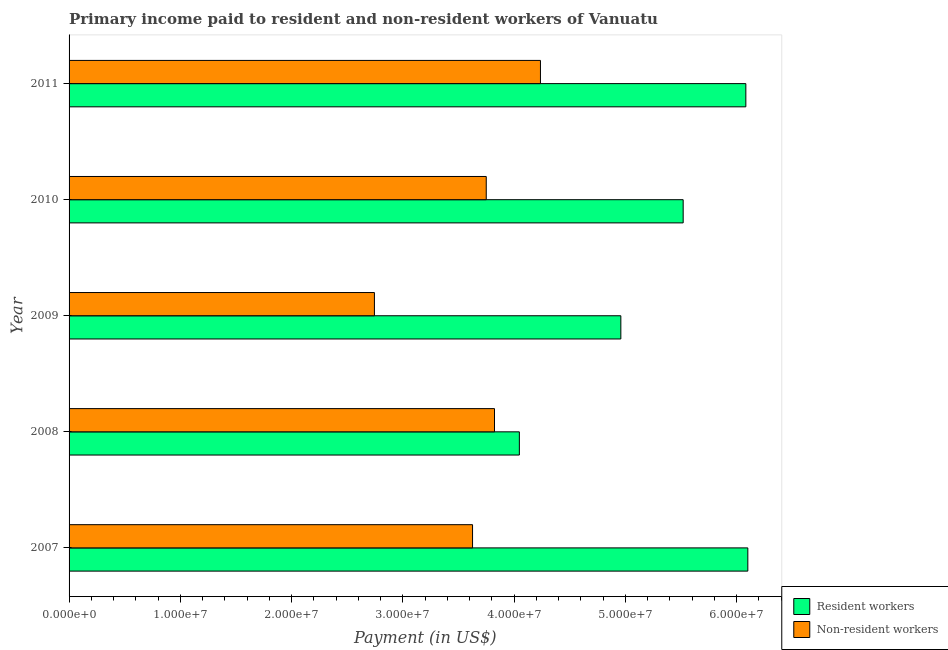How many groups of bars are there?
Your response must be concise. 5. Are the number of bars per tick equal to the number of legend labels?
Your response must be concise. Yes. How many bars are there on the 3rd tick from the top?
Your answer should be compact. 2. What is the payment made to resident workers in 2008?
Your response must be concise. 4.05e+07. Across all years, what is the maximum payment made to resident workers?
Give a very brief answer. 6.10e+07. Across all years, what is the minimum payment made to non-resident workers?
Offer a terse response. 2.74e+07. What is the total payment made to resident workers in the graph?
Keep it short and to the point. 2.67e+08. What is the difference between the payment made to non-resident workers in 2009 and that in 2011?
Give a very brief answer. -1.49e+07. What is the difference between the payment made to non-resident workers in 2008 and the payment made to resident workers in 2011?
Your answer should be very brief. -2.26e+07. What is the average payment made to resident workers per year?
Provide a short and direct response. 5.34e+07. In the year 2008, what is the difference between the payment made to resident workers and payment made to non-resident workers?
Your response must be concise. 2.23e+06. In how many years, is the payment made to resident workers greater than 26000000 US$?
Your answer should be very brief. 5. What is the ratio of the payment made to resident workers in 2007 to that in 2008?
Make the answer very short. 1.51. Is the payment made to resident workers in 2007 less than that in 2010?
Your answer should be very brief. No. Is the difference between the payment made to resident workers in 2008 and 2011 greater than the difference between the payment made to non-resident workers in 2008 and 2011?
Keep it short and to the point. No. What is the difference between the highest and the second highest payment made to non-resident workers?
Give a very brief answer. 4.13e+06. What is the difference between the highest and the lowest payment made to resident workers?
Keep it short and to the point. 2.05e+07. What does the 2nd bar from the top in 2010 represents?
Keep it short and to the point. Resident workers. What does the 2nd bar from the bottom in 2009 represents?
Keep it short and to the point. Non-resident workers. How many bars are there?
Provide a succinct answer. 10. Are all the bars in the graph horizontal?
Your answer should be compact. Yes. What is the difference between two consecutive major ticks on the X-axis?
Provide a short and direct response. 1.00e+07. Does the graph contain any zero values?
Make the answer very short. No. Does the graph contain grids?
Your answer should be very brief. No. How many legend labels are there?
Give a very brief answer. 2. What is the title of the graph?
Your answer should be compact. Primary income paid to resident and non-resident workers of Vanuatu. Does "Domestic liabilities" appear as one of the legend labels in the graph?
Your response must be concise. No. What is the label or title of the X-axis?
Provide a succinct answer. Payment (in US$). What is the label or title of the Y-axis?
Offer a terse response. Year. What is the Payment (in US$) in Resident workers in 2007?
Keep it short and to the point. 6.10e+07. What is the Payment (in US$) of Non-resident workers in 2007?
Make the answer very short. 3.63e+07. What is the Payment (in US$) of Resident workers in 2008?
Keep it short and to the point. 4.05e+07. What is the Payment (in US$) in Non-resident workers in 2008?
Keep it short and to the point. 3.82e+07. What is the Payment (in US$) in Resident workers in 2009?
Provide a succinct answer. 4.96e+07. What is the Payment (in US$) in Non-resident workers in 2009?
Ensure brevity in your answer.  2.74e+07. What is the Payment (in US$) of Resident workers in 2010?
Give a very brief answer. 5.52e+07. What is the Payment (in US$) in Non-resident workers in 2010?
Give a very brief answer. 3.75e+07. What is the Payment (in US$) in Resident workers in 2011?
Provide a short and direct response. 6.08e+07. What is the Payment (in US$) of Non-resident workers in 2011?
Give a very brief answer. 4.24e+07. Across all years, what is the maximum Payment (in US$) of Resident workers?
Your answer should be very brief. 6.10e+07. Across all years, what is the maximum Payment (in US$) of Non-resident workers?
Ensure brevity in your answer.  4.24e+07. Across all years, what is the minimum Payment (in US$) of Resident workers?
Make the answer very short. 4.05e+07. Across all years, what is the minimum Payment (in US$) of Non-resident workers?
Make the answer very short. 2.74e+07. What is the total Payment (in US$) in Resident workers in the graph?
Offer a terse response. 2.67e+08. What is the total Payment (in US$) in Non-resident workers in the graph?
Give a very brief answer. 1.82e+08. What is the difference between the Payment (in US$) in Resident workers in 2007 and that in 2008?
Ensure brevity in your answer.  2.05e+07. What is the difference between the Payment (in US$) of Non-resident workers in 2007 and that in 2008?
Your response must be concise. -1.97e+06. What is the difference between the Payment (in US$) in Resident workers in 2007 and that in 2009?
Offer a terse response. 1.14e+07. What is the difference between the Payment (in US$) of Non-resident workers in 2007 and that in 2009?
Provide a succinct answer. 8.82e+06. What is the difference between the Payment (in US$) of Resident workers in 2007 and that in 2010?
Make the answer very short. 5.81e+06. What is the difference between the Payment (in US$) in Non-resident workers in 2007 and that in 2010?
Keep it short and to the point. -1.23e+06. What is the difference between the Payment (in US$) of Resident workers in 2007 and that in 2011?
Give a very brief answer. 1.78e+05. What is the difference between the Payment (in US$) in Non-resident workers in 2007 and that in 2011?
Your answer should be compact. -6.10e+06. What is the difference between the Payment (in US$) in Resident workers in 2008 and that in 2009?
Provide a succinct answer. -9.12e+06. What is the difference between the Payment (in US$) in Non-resident workers in 2008 and that in 2009?
Your response must be concise. 1.08e+07. What is the difference between the Payment (in US$) of Resident workers in 2008 and that in 2010?
Offer a very short reply. -1.47e+07. What is the difference between the Payment (in US$) of Non-resident workers in 2008 and that in 2010?
Ensure brevity in your answer.  7.41e+05. What is the difference between the Payment (in US$) in Resident workers in 2008 and that in 2011?
Your answer should be compact. -2.04e+07. What is the difference between the Payment (in US$) in Non-resident workers in 2008 and that in 2011?
Your answer should be very brief. -4.13e+06. What is the difference between the Payment (in US$) in Resident workers in 2009 and that in 2010?
Give a very brief answer. -5.60e+06. What is the difference between the Payment (in US$) of Non-resident workers in 2009 and that in 2010?
Your answer should be very brief. -1.01e+07. What is the difference between the Payment (in US$) of Resident workers in 2009 and that in 2011?
Ensure brevity in your answer.  -1.12e+07. What is the difference between the Payment (in US$) in Non-resident workers in 2009 and that in 2011?
Offer a very short reply. -1.49e+07. What is the difference between the Payment (in US$) of Resident workers in 2010 and that in 2011?
Your response must be concise. -5.63e+06. What is the difference between the Payment (in US$) in Non-resident workers in 2010 and that in 2011?
Provide a succinct answer. -4.87e+06. What is the difference between the Payment (in US$) of Resident workers in 2007 and the Payment (in US$) of Non-resident workers in 2008?
Your answer should be compact. 2.28e+07. What is the difference between the Payment (in US$) in Resident workers in 2007 and the Payment (in US$) in Non-resident workers in 2009?
Provide a short and direct response. 3.36e+07. What is the difference between the Payment (in US$) in Resident workers in 2007 and the Payment (in US$) in Non-resident workers in 2010?
Give a very brief answer. 2.35e+07. What is the difference between the Payment (in US$) of Resident workers in 2007 and the Payment (in US$) of Non-resident workers in 2011?
Your answer should be compact. 1.86e+07. What is the difference between the Payment (in US$) of Resident workers in 2008 and the Payment (in US$) of Non-resident workers in 2009?
Your response must be concise. 1.30e+07. What is the difference between the Payment (in US$) in Resident workers in 2008 and the Payment (in US$) in Non-resident workers in 2010?
Your response must be concise. 2.98e+06. What is the difference between the Payment (in US$) of Resident workers in 2008 and the Payment (in US$) of Non-resident workers in 2011?
Your answer should be compact. -1.90e+06. What is the difference between the Payment (in US$) in Resident workers in 2009 and the Payment (in US$) in Non-resident workers in 2010?
Your response must be concise. 1.21e+07. What is the difference between the Payment (in US$) in Resident workers in 2009 and the Payment (in US$) in Non-resident workers in 2011?
Provide a succinct answer. 7.23e+06. What is the difference between the Payment (in US$) of Resident workers in 2010 and the Payment (in US$) of Non-resident workers in 2011?
Provide a short and direct response. 1.28e+07. What is the average Payment (in US$) of Resident workers per year?
Offer a terse response. 5.34e+07. What is the average Payment (in US$) of Non-resident workers per year?
Give a very brief answer. 3.64e+07. In the year 2007, what is the difference between the Payment (in US$) in Resident workers and Payment (in US$) in Non-resident workers?
Provide a succinct answer. 2.47e+07. In the year 2008, what is the difference between the Payment (in US$) of Resident workers and Payment (in US$) of Non-resident workers?
Keep it short and to the point. 2.23e+06. In the year 2009, what is the difference between the Payment (in US$) in Resident workers and Payment (in US$) in Non-resident workers?
Provide a short and direct response. 2.21e+07. In the year 2010, what is the difference between the Payment (in US$) in Resident workers and Payment (in US$) in Non-resident workers?
Ensure brevity in your answer.  1.77e+07. In the year 2011, what is the difference between the Payment (in US$) of Resident workers and Payment (in US$) of Non-resident workers?
Your response must be concise. 1.85e+07. What is the ratio of the Payment (in US$) of Resident workers in 2007 to that in 2008?
Offer a very short reply. 1.51. What is the ratio of the Payment (in US$) of Non-resident workers in 2007 to that in 2008?
Your answer should be compact. 0.95. What is the ratio of the Payment (in US$) of Resident workers in 2007 to that in 2009?
Your answer should be compact. 1.23. What is the ratio of the Payment (in US$) of Non-resident workers in 2007 to that in 2009?
Your response must be concise. 1.32. What is the ratio of the Payment (in US$) in Resident workers in 2007 to that in 2010?
Ensure brevity in your answer.  1.11. What is the ratio of the Payment (in US$) in Non-resident workers in 2007 to that in 2010?
Offer a very short reply. 0.97. What is the ratio of the Payment (in US$) of Non-resident workers in 2007 to that in 2011?
Give a very brief answer. 0.86. What is the ratio of the Payment (in US$) of Resident workers in 2008 to that in 2009?
Your response must be concise. 0.82. What is the ratio of the Payment (in US$) of Non-resident workers in 2008 to that in 2009?
Make the answer very short. 1.39. What is the ratio of the Payment (in US$) in Resident workers in 2008 to that in 2010?
Your response must be concise. 0.73. What is the ratio of the Payment (in US$) of Non-resident workers in 2008 to that in 2010?
Offer a very short reply. 1.02. What is the ratio of the Payment (in US$) in Resident workers in 2008 to that in 2011?
Your response must be concise. 0.67. What is the ratio of the Payment (in US$) in Non-resident workers in 2008 to that in 2011?
Offer a terse response. 0.9. What is the ratio of the Payment (in US$) in Resident workers in 2009 to that in 2010?
Keep it short and to the point. 0.9. What is the ratio of the Payment (in US$) in Non-resident workers in 2009 to that in 2010?
Offer a very short reply. 0.73. What is the ratio of the Payment (in US$) in Resident workers in 2009 to that in 2011?
Give a very brief answer. 0.82. What is the ratio of the Payment (in US$) in Non-resident workers in 2009 to that in 2011?
Your answer should be compact. 0.65. What is the ratio of the Payment (in US$) in Resident workers in 2010 to that in 2011?
Your response must be concise. 0.91. What is the ratio of the Payment (in US$) in Non-resident workers in 2010 to that in 2011?
Your response must be concise. 0.89. What is the difference between the highest and the second highest Payment (in US$) in Resident workers?
Provide a succinct answer. 1.78e+05. What is the difference between the highest and the second highest Payment (in US$) of Non-resident workers?
Provide a succinct answer. 4.13e+06. What is the difference between the highest and the lowest Payment (in US$) in Resident workers?
Your answer should be compact. 2.05e+07. What is the difference between the highest and the lowest Payment (in US$) of Non-resident workers?
Offer a very short reply. 1.49e+07. 